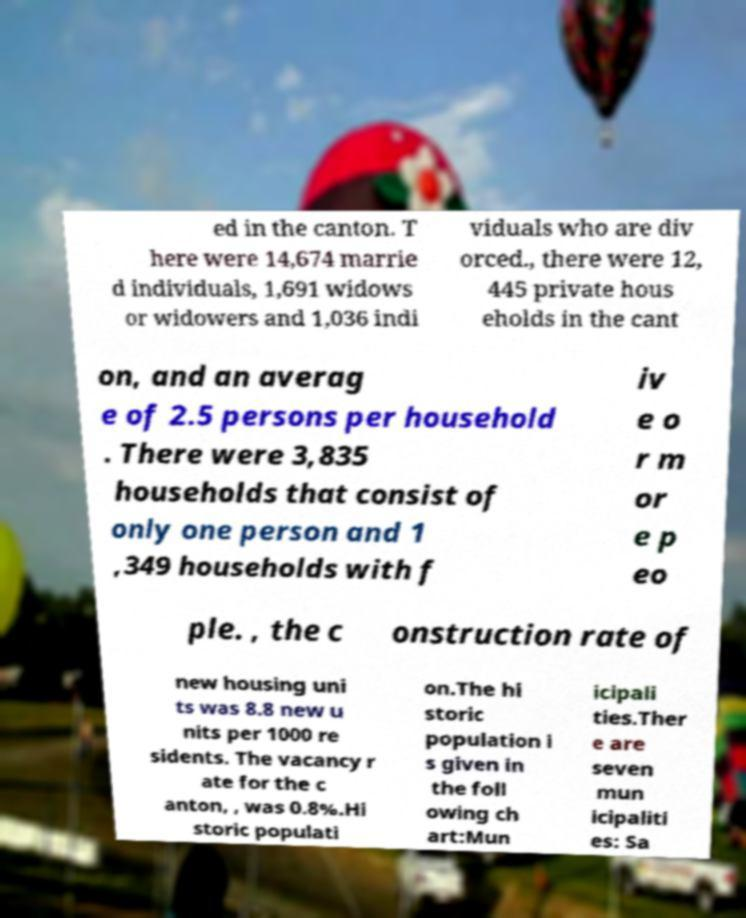I need the written content from this picture converted into text. Can you do that? ed in the canton. T here were 14,674 marrie d individuals, 1,691 widows or widowers and 1,036 indi viduals who are div orced., there were 12, 445 private hous eholds in the cant on, and an averag e of 2.5 persons per household . There were 3,835 households that consist of only one person and 1 ,349 households with f iv e o r m or e p eo ple. , the c onstruction rate of new housing uni ts was 8.8 new u nits per 1000 re sidents. The vacancy r ate for the c anton, , was 0.8%.Hi storic populati on.The hi storic population i s given in the foll owing ch art:Mun icipali ties.Ther e are seven mun icipaliti es: Sa 